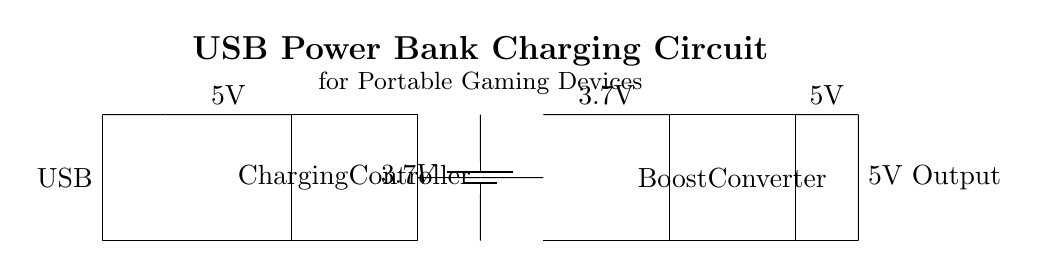What is the input voltage for this circuit? The input voltage is indicated at the top of the circuit diagram where it shows the USB label; the standard USB output voltage is 5V.
Answer: 5V What component is used to boost the battery voltage? The component labeled as "Boost Converter" is responsible for stepping up the battery voltage from 3.7V to a higher level suitable for the output.
Answer: Boost Converter What is the voltage of the battery in this circuit? The battery is specifically labeled with a voltage of 3.7V within the circuit diagram, indicating its nominal voltage.
Answer: 3.7V How many primary components are present in this circuit? Counting the components present, there are four main elements: USB input, charging controller, battery, and boost converter.
Answer: Four What is the purpose of the charging controller? The charging controller's purpose is to manage the charging process of the battery, ensuring safe and efficient charging from the USB power source.
Answer: Manage charging What output voltage does the circuit provide? At the output side of the circuit, it is clearly labeled as 5V, indicating the voltage supplied to the portable gaming devices.
Answer: 5V What connections are made between the components in the charging circuit? The connections include links from the USB input to the charging controller, from the charging controller to the battery, and then from the battery to the boost converter, ultimately leading to the output.
Answer: USB to charging controller to battery to boost converter to output 